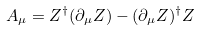<formula> <loc_0><loc_0><loc_500><loc_500>A _ { \mu } = Z ^ { \dag } ( \partial _ { \mu } Z ) - ( \partial _ { \mu } Z ) ^ { \dag } Z</formula> 